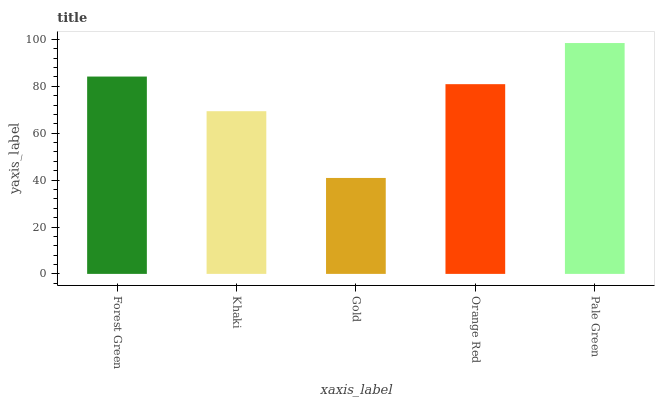Is Gold the minimum?
Answer yes or no. Yes. Is Pale Green the maximum?
Answer yes or no. Yes. Is Khaki the minimum?
Answer yes or no. No. Is Khaki the maximum?
Answer yes or no. No. Is Forest Green greater than Khaki?
Answer yes or no. Yes. Is Khaki less than Forest Green?
Answer yes or no. Yes. Is Khaki greater than Forest Green?
Answer yes or no. No. Is Forest Green less than Khaki?
Answer yes or no. No. Is Orange Red the high median?
Answer yes or no. Yes. Is Orange Red the low median?
Answer yes or no. Yes. Is Pale Green the high median?
Answer yes or no. No. Is Pale Green the low median?
Answer yes or no. No. 